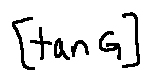<formula> <loc_0><loc_0><loc_500><loc_500>[ \tan G ]</formula> 